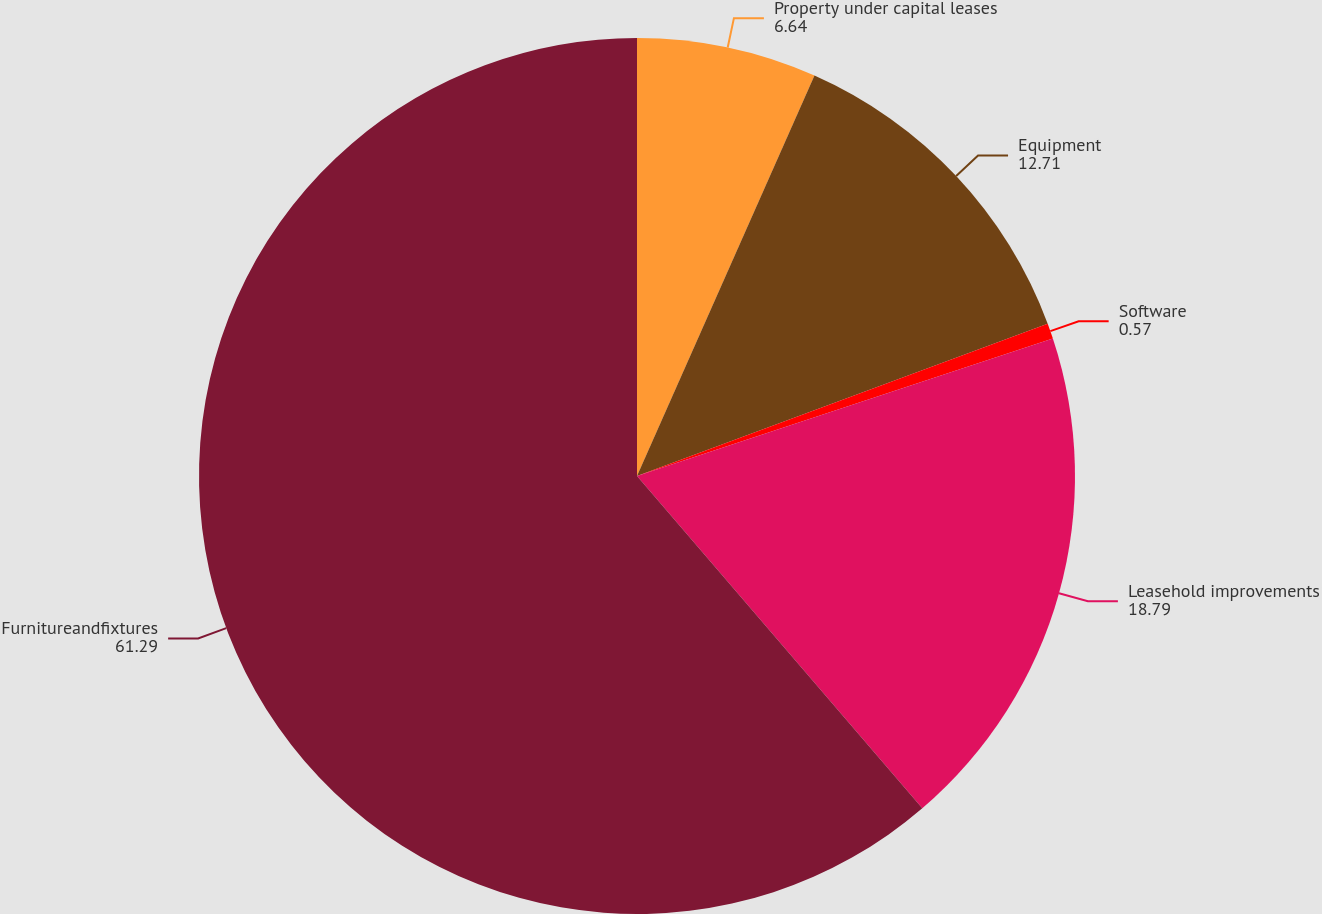Convert chart to OTSL. <chart><loc_0><loc_0><loc_500><loc_500><pie_chart><fcel>Property under capital leases<fcel>Equipment<fcel>Software<fcel>Leasehold improvements<fcel>Furnitureandfixtures<nl><fcel>6.64%<fcel>12.71%<fcel>0.57%<fcel>18.79%<fcel>61.29%<nl></chart> 